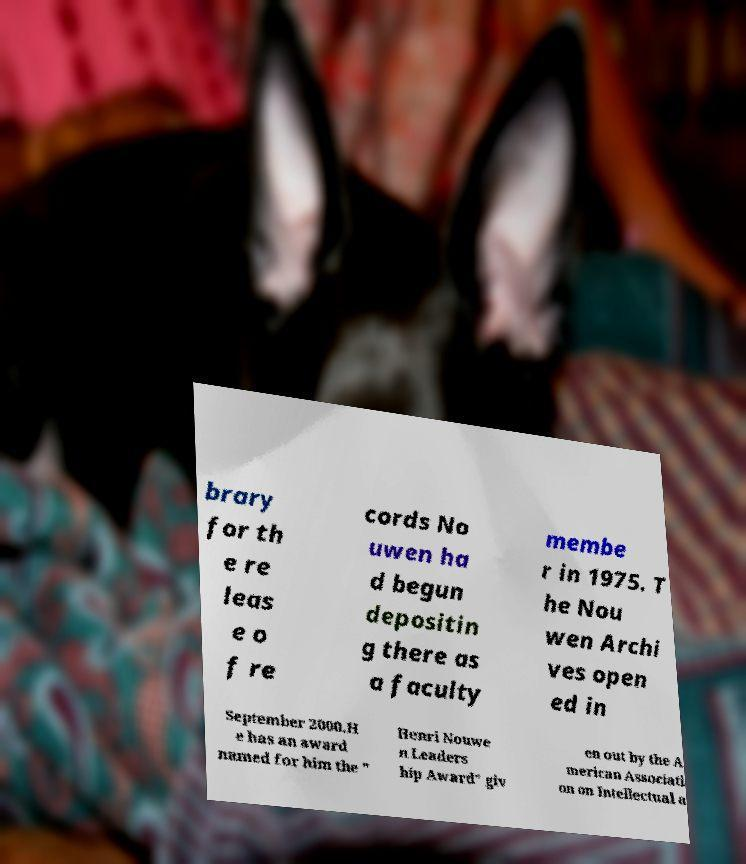Please read and relay the text visible in this image. What does it say? brary for th e re leas e o f re cords No uwen ha d begun depositin g there as a faculty membe r in 1975. T he Nou wen Archi ves open ed in September 2000.H e has an award named for him the " Henri Nouwe n Leaders hip Award" giv en out by the A merican Associati on on Intellectual a 